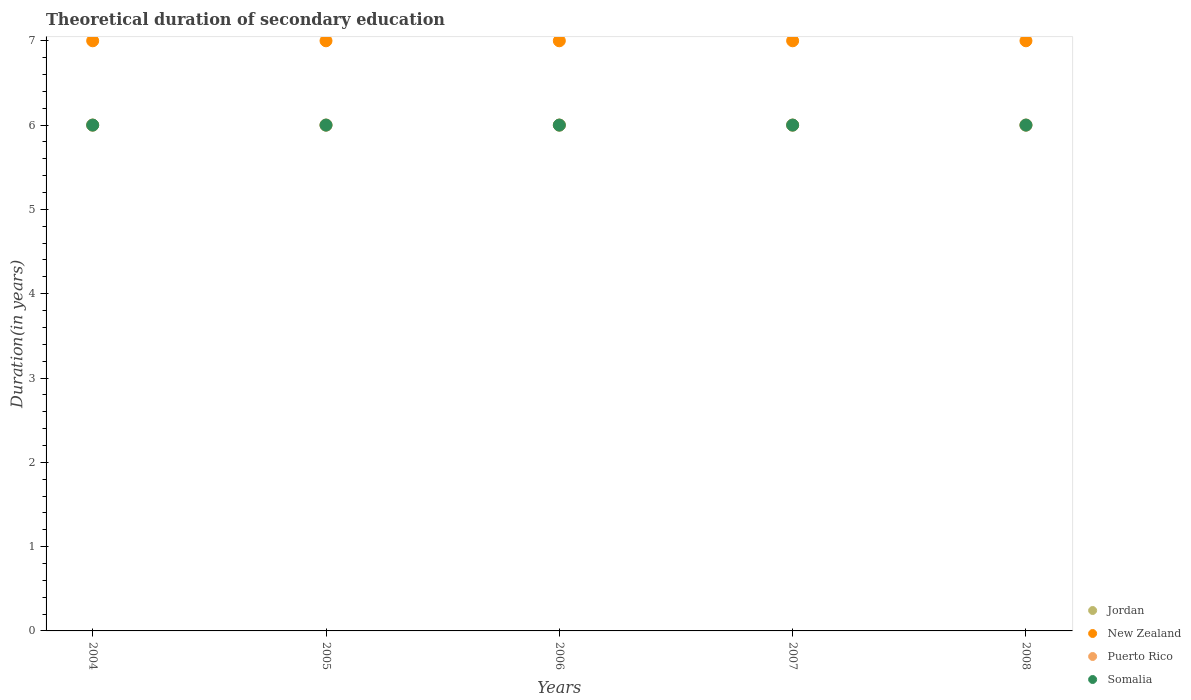What is the total theoretical duration of secondary education in New Zealand in 2004?
Give a very brief answer. 7. Across all years, what is the maximum total theoretical duration of secondary education in Jordan?
Your response must be concise. 6. In which year was the total theoretical duration of secondary education in Somalia maximum?
Your answer should be very brief. 2004. What is the total total theoretical duration of secondary education in New Zealand in the graph?
Keep it short and to the point. 35. What is the difference between the total theoretical duration of secondary education in Jordan in 2004 and that in 2008?
Your answer should be compact. 0. What is the difference between the total theoretical duration of secondary education in Jordan in 2006 and the total theoretical duration of secondary education in New Zealand in 2008?
Your answer should be compact. -1. In how many years, is the total theoretical duration of secondary education in New Zealand greater than 6.4 years?
Make the answer very short. 5. Is the total theoretical duration of secondary education in New Zealand in 2004 less than that in 2005?
Your response must be concise. No. In how many years, is the total theoretical duration of secondary education in Somalia greater than the average total theoretical duration of secondary education in Somalia taken over all years?
Make the answer very short. 0. Is it the case that in every year, the sum of the total theoretical duration of secondary education in New Zealand and total theoretical duration of secondary education in Puerto Rico  is greater than the total theoretical duration of secondary education in Somalia?
Your answer should be very brief. Yes. Does the total theoretical duration of secondary education in Jordan monotonically increase over the years?
Keep it short and to the point. No. Is the total theoretical duration of secondary education in Somalia strictly greater than the total theoretical duration of secondary education in New Zealand over the years?
Give a very brief answer. No. Is the total theoretical duration of secondary education in New Zealand strictly less than the total theoretical duration of secondary education in Puerto Rico over the years?
Your answer should be compact. No. What is the difference between two consecutive major ticks on the Y-axis?
Ensure brevity in your answer.  1. Are the values on the major ticks of Y-axis written in scientific E-notation?
Make the answer very short. No. Does the graph contain any zero values?
Ensure brevity in your answer.  No. Does the graph contain grids?
Make the answer very short. No. Where does the legend appear in the graph?
Provide a succinct answer. Bottom right. How many legend labels are there?
Your answer should be very brief. 4. What is the title of the graph?
Your answer should be compact. Theoretical duration of secondary education. Does "Equatorial Guinea" appear as one of the legend labels in the graph?
Your answer should be compact. No. What is the label or title of the Y-axis?
Give a very brief answer. Duration(in years). What is the Duration(in years) in Jordan in 2004?
Offer a terse response. 6. What is the Duration(in years) in New Zealand in 2005?
Give a very brief answer. 7. What is the Duration(in years) in Puerto Rico in 2005?
Ensure brevity in your answer.  6. What is the Duration(in years) of New Zealand in 2006?
Give a very brief answer. 7. What is the Duration(in years) in Somalia in 2006?
Offer a very short reply. 6. What is the Duration(in years) of Puerto Rico in 2007?
Give a very brief answer. 6. What is the Duration(in years) in Somalia in 2007?
Ensure brevity in your answer.  6. What is the Duration(in years) of Puerto Rico in 2008?
Your response must be concise. 6. What is the Duration(in years) in Somalia in 2008?
Offer a terse response. 6. Across all years, what is the minimum Duration(in years) of Jordan?
Keep it short and to the point. 6. What is the total Duration(in years) of New Zealand in the graph?
Give a very brief answer. 35. What is the total Duration(in years) of Puerto Rico in the graph?
Make the answer very short. 30. What is the difference between the Duration(in years) in Somalia in 2004 and that in 2007?
Offer a very short reply. 0. What is the difference between the Duration(in years) in New Zealand in 2005 and that in 2006?
Provide a succinct answer. 0. What is the difference between the Duration(in years) of Somalia in 2005 and that in 2006?
Make the answer very short. 0. What is the difference between the Duration(in years) of Puerto Rico in 2005 and that in 2007?
Offer a terse response. 0. What is the difference between the Duration(in years) in Somalia in 2005 and that in 2007?
Give a very brief answer. 0. What is the difference between the Duration(in years) in Jordan in 2005 and that in 2008?
Ensure brevity in your answer.  0. What is the difference between the Duration(in years) in Somalia in 2005 and that in 2008?
Your answer should be very brief. 0. What is the difference between the Duration(in years) of Jordan in 2006 and that in 2007?
Offer a very short reply. 0. What is the difference between the Duration(in years) of New Zealand in 2006 and that in 2007?
Your response must be concise. 0. What is the difference between the Duration(in years) of Puerto Rico in 2006 and that in 2007?
Give a very brief answer. 0. What is the difference between the Duration(in years) of Jordan in 2006 and that in 2008?
Ensure brevity in your answer.  0. What is the difference between the Duration(in years) in New Zealand in 2006 and that in 2008?
Keep it short and to the point. 0. What is the difference between the Duration(in years) of Somalia in 2006 and that in 2008?
Your answer should be very brief. 0. What is the difference between the Duration(in years) in Jordan in 2007 and that in 2008?
Ensure brevity in your answer.  0. What is the difference between the Duration(in years) of Jordan in 2004 and the Duration(in years) of Somalia in 2005?
Your answer should be compact. 0. What is the difference between the Duration(in years) in New Zealand in 2004 and the Duration(in years) in Puerto Rico in 2005?
Offer a very short reply. 1. What is the difference between the Duration(in years) of New Zealand in 2004 and the Duration(in years) of Somalia in 2005?
Give a very brief answer. 1. What is the difference between the Duration(in years) in Puerto Rico in 2004 and the Duration(in years) in Somalia in 2005?
Give a very brief answer. 0. What is the difference between the Duration(in years) of Jordan in 2004 and the Duration(in years) of New Zealand in 2006?
Provide a short and direct response. -1. What is the difference between the Duration(in years) of Jordan in 2004 and the Duration(in years) of Somalia in 2006?
Offer a terse response. 0. What is the difference between the Duration(in years) of New Zealand in 2004 and the Duration(in years) of Puerto Rico in 2006?
Provide a succinct answer. 1. What is the difference between the Duration(in years) of New Zealand in 2004 and the Duration(in years) of Somalia in 2006?
Provide a succinct answer. 1. What is the difference between the Duration(in years) in Jordan in 2004 and the Duration(in years) in New Zealand in 2007?
Provide a short and direct response. -1. What is the difference between the Duration(in years) in Jordan in 2004 and the Duration(in years) in Puerto Rico in 2007?
Offer a terse response. 0. What is the difference between the Duration(in years) in Jordan in 2004 and the Duration(in years) in Somalia in 2007?
Keep it short and to the point. 0. What is the difference between the Duration(in years) in New Zealand in 2004 and the Duration(in years) in Somalia in 2007?
Provide a succinct answer. 1. What is the difference between the Duration(in years) in Puerto Rico in 2004 and the Duration(in years) in Somalia in 2007?
Offer a very short reply. 0. What is the difference between the Duration(in years) of Jordan in 2004 and the Duration(in years) of Puerto Rico in 2008?
Provide a short and direct response. 0. What is the difference between the Duration(in years) of New Zealand in 2004 and the Duration(in years) of Puerto Rico in 2008?
Offer a very short reply. 1. What is the difference between the Duration(in years) of New Zealand in 2004 and the Duration(in years) of Somalia in 2008?
Your answer should be very brief. 1. What is the difference between the Duration(in years) in Puerto Rico in 2004 and the Duration(in years) in Somalia in 2008?
Ensure brevity in your answer.  0. What is the difference between the Duration(in years) in Jordan in 2005 and the Duration(in years) in New Zealand in 2006?
Your response must be concise. -1. What is the difference between the Duration(in years) of Jordan in 2005 and the Duration(in years) of Puerto Rico in 2006?
Your answer should be very brief. 0. What is the difference between the Duration(in years) in Puerto Rico in 2005 and the Duration(in years) in Somalia in 2006?
Your answer should be very brief. 0. What is the difference between the Duration(in years) in Jordan in 2005 and the Duration(in years) in New Zealand in 2007?
Ensure brevity in your answer.  -1. What is the difference between the Duration(in years) in Jordan in 2005 and the Duration(in years) in Puerto Rico in 2007?
Your response must be concise. 0. What is the difference between the Duration(in years) in Jordan in 2005 and the Duration(in years) in Somalia in 2007?
Provide a succinct answer. 0. What is the difference between the Duration(in years) in New Zealand in 2005 and the Duration(in years) in Somalia in 2007?
Make the answer very short. 1. What is the difference between the Duration(in years) of Jordan in 2005 and the Duration(in years) of New Zealand in 2008?
Provide a succinct answer. -1. What is the difference between the Duration(in years) in New Zealand in 2005 and the Duration(in years) in Puerto Rico in 2008?
Provide a short and direct response. 1. What is the difference between the Duration(in years) of New Zealand in 2005 and the Duration(in years) of Somalia in 2008?
Give a very brief answer. 1. What is the difference between the Duration(in years) of Puerto Rico in 2005 and the Duration(in years) of Somalia in 2008?
Offer a terse response. 0. What is the difference between the Duration(in years) in Jordan in 2006 and the Duration(in years) in New Zealand in 2007?
Your response must be concise. -1. What is the difference between the Duration(in years) in Jordan in 2006 and the Duration(in years) in Puerto Rico in 2007?
Give a very brief answer. 0. What is the difference between the Duration(in years) of New Zealand in 2006 and the Duration(in years) of Puerto Rico in 2007?
Make the answer very short. 1. What is the difference between the Duration(in years) in Puerto Rico in 2006 and the Duration(in years) in Somalia in 2007?
Your answer should be very brief. 0. What is the difference between the Duration(in years) in Jordan in 2006 and the Duration(in years) in New Zealand in 2008?
Provide a short and direct response. -1. What is the difference between the Duration(in years) in Jordan in 2006 and the Duration(in years) in Somalia in 2008?
Make the answer very short. 0. What is the difference between the Duration(in years) in New Zealand in 2006 and the Duration(in years) in Somalia in 2008?
Make the answer very short. 1. What is the difference between the Duration(in years) of Puerto Rico in 2006 and the Duration(in years) of Somalia in 2008?
Provide a short and direct response. 0. What is the difference between the Duration(in years) of Jordan in 2007 and the Duration(in years) of Puerto Rico in 2008?
Your answer should be very brief. 0. What is the difference between the Duration(in years) in New Zealand in 2007 and the Duration(in years) in Puerto Rico in 2008?
Offer a terse response. 1. What is the difference between the Duration(in years) of Puerto Rico in 2007 and the Duration(in years) of Somalia in 2008?
Give a very brief answer. 0. What is the average Duration(in years) in Jordan per year?
Give a very brief answer. 6. What is the average Duration(in years) of New Zealand per year?
Offer a terse response. 7. What is the average Duration(in years) of Puerto Rico per year?
Your answer should be very brief. 6. In the year 2004, what is the difference between the Duration(in years) of Jordan and Duration(in years) of New Zealand?
Your response must be concise. -1. In the year 2004, what is the difference between the Duration(in years) of Jordan and Duration(in years) of Puerto Rico?
Offer a terse response. 0. In the year 2004, what is the difference between the Duration(in years) in Puerto Rico and Duration(in years) in Somalia?
Ensure brevity in your answer.  0. In the year 2005, what is the difference between the Duration(in years) in Jordan and Duration(in years) in New Zealand?
Make the answer very short. -1. In the year 2005, what is the difference between the Duration(in years) in Jordan and Duration(in years) in Somalia?
Provide a short and direct response. 0. In the year 2005, what is the difference between the Duration(in years) of New Zealand and Duration(in years) of Puerto Rico?
Give a very brief answer. 1. In the year 2005, what is the difference between the Duration(in years) of New Zealand and Duration(in years) of Somalia?
Provide a short and direct response. 1. In the year 2005, what is the difference between the Duration(in years) of Puerto Rico and Duration(in years) of Somalia?
Offer a very short reply. 0. In the year 2006, what is the difference between the Duration(in years) in Jordan and Duration(in years) in Somalia?
Provide a succinct answer. 0. In the year 2006, what is the difference between the Duration(in years) of New Zealand and Duration(in years) of Somalia?
Your answer should be very brief. 1. In the year 2006, what is the difference between the Duration(in years) of Puerto Rico and Duration(in years) of Somalia?
Your answer should be compact. 0. In the year 2007, what is the difference between the Duration(in years) of Jordan and Duration(in years) of Somalia?
Give a very brief answer. 0. In the year 2007, what is the difference between the Duration(in years) of New Zealand and Duration(in years) of Somalia?
Offer a very short reply. 1. In the year 2008, what is the difference between the Duration(in years) in Jordan and Duration(in years) in Puerto Rico?
Ensure brevity in your answer.  0. In the year 2008, what is the difference between the Duration(in years) in New Zealand and Duration(in years) in Puerto Rico?
Your answer should be compact. 1. What is the ratio of the Duration(in years) in Jordan in 2004 to that in 2005?
Offer a very short reply. 1. What is the ratio of the Duration(in years) in Puerto Rico in 2004 to that in 2005?
Provide a succinct answer. 1. What is the ratio of the Duration(in years) in New Zealand in 2004 to that in 2006?
Offer a very short reply. 1. What is the ratio of the Duration(in years) of Puerto Rico in 2004 to that in 2006?
Offer a terse response. 1. What is the ratio of the Duration(in years) in Somalia in 2004 to that in 2006?
Give a very brief answer. 1. What is the ratio of the Duration(in years) in New Zealand in 2004 to that in 2007?
Your answer should be very brief. 1. What is the ratio of the Duration(in years) in Somalia in 2004 to that in 2007?
Ensure brevity in your answer.  1. What is the ratio of the Duration(in years) in New Zealand in 2005 to that in 2006?
Make the answer very short. 1. What is the ratio of the Duration(in years) of Somalia in 2005 to that in 2006?
Provide a short and direct response. 1. What is the ratio of the Duration(in years) of Jordan in 2005 to that in 2007?
Keep it short and to the point. 1. What is the ratio of the Duration(in years) in Puerto Rico in 2005 to that in 2008?
Ensure brevity in your answer.  1. What is the ratio of the Duration(in years) in Somalia in 2005 to that in 2008?
Offer a very short reply. 1. What is the ratio of the Duration(in years) of Jordan in 2006 to that in 2007?
Your response must be concise. 1. What is the ratio of the Duration(in years) of New Zealand in 2006 to that in 2007?
Offer a terse response. 1. What is the ratio of the Duration(in years) of Jordan in 2006 to that in 2008?
Ensure brevity in your answer.  1. What is the ratio of the Duration(in years) of Puerto Rico in 2006 to that in 2008?
Your response must be concise. 1. What is the ratio of the Duration(in years) of New Zealand in 2007 to that in 2008?
Your response must be concise. 1. What is the difference between the highest and the second highest Duration(in years) of Somalia?
Keep it short and to the point. 0. What is the difference between the highest and the lowest Duration(in years) of Jordan?
Provide a succinct answer. 0. What is the difference between the highest and the lowest Duration(in years) of Puerto Rico?
Provide a short and direct response. 0. What is the difference between the highest and the lowest Duration(in years) in Somalia?
Ensure brevity in your answer.  0. 